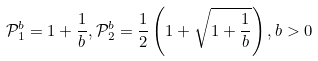Convert formula to latex. <formula><loc_0><loc_0><loc_500><loc_500>\mathcal { P } _ { 1 } ^ { b } = 1 + \frac { 1 } { b } , \mathcal { P } _ { 2 } ^ { b } = \frac { 1 } { 2 } \left ( 1 + \sqrt { 1 + \frac { 1 } { b } } \right ) , b > 0</formula> 